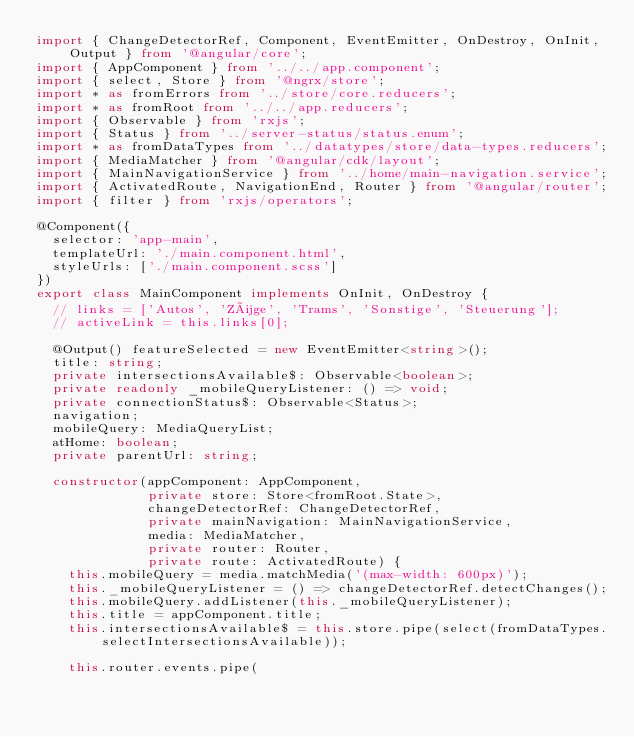<code> <loc_0><loc_0><loc_500><loc_500><_TypeScript_>import { ChangeDetectorRef, Component, EventEmitter, OnDestroy, OnInit, Output } from '@angular/core';
import { AppComponent } from '../../app.component';
import { select, Store } from '@ngrx/store';
import * as fromErrors from '../store/core.reducers';
import * as fromRoot from '../../app.reducers';
import { Observable } from 'rxjs';
import { Status } from '../server-status/status.enum';
import * as fromDataTypes from '../datatypes/store/data-types.reducers';
import { MediaMatcher } from '@angular/cdk/layout';
import { MainNavigationService } from '../home/main-navigation.service';
import { ActivatedRoute, NavigationEnd, Router } from '@angular/router';
import { filter } from 'rxjs/operators';

@Component({
  selector: 'app-main',
  templateUrl: './main.component.html',
  styleUrls: ['./main.component.scss']
})
export class MainComponent implements OnInit, OnDestroy {
  // links = ['Autos', 'Züge', 'Trams', 'Sonstige', 'Steuerung'];
  // activeLink = this.links[0];

  @Output() featureSelected = new EventEmitter<string>();
  title: string;
  private intersectionsAvailable$: Observable<boolean>;
  private readonly _mobileQueryListener: () => void;
  private connectionStatus$: Observable<Status>;
  navigation;
  mobileQuery: MediaQueryList;
  atHome: boolean;
  private parentUrl: string;

  constructor(appComponent: AppComponent,
              private store: Store<fromRoot.State>,
              changeDetectorRef: ChangeDetectorRef,
              private mainNavigation: MainNavigationService,
              media: MediaMatcher,
              private router: Router,
              private route: ActivatedRoute) {
    this.mobileQuery = media.matchMedia('(max-width: 600px)');
    this._mobileQueryListener = () => changeDetectorRef.detectChanges();
    this.mobileQuery.addListener(this._mobileQueryListener);
    this.title = appComponent.title;
    this.intersectionsAvailable$ = this.store.pipe(select(fromDataTypes.selectIntersectionsAvailable));

    this.router.events.pipe(</code> 